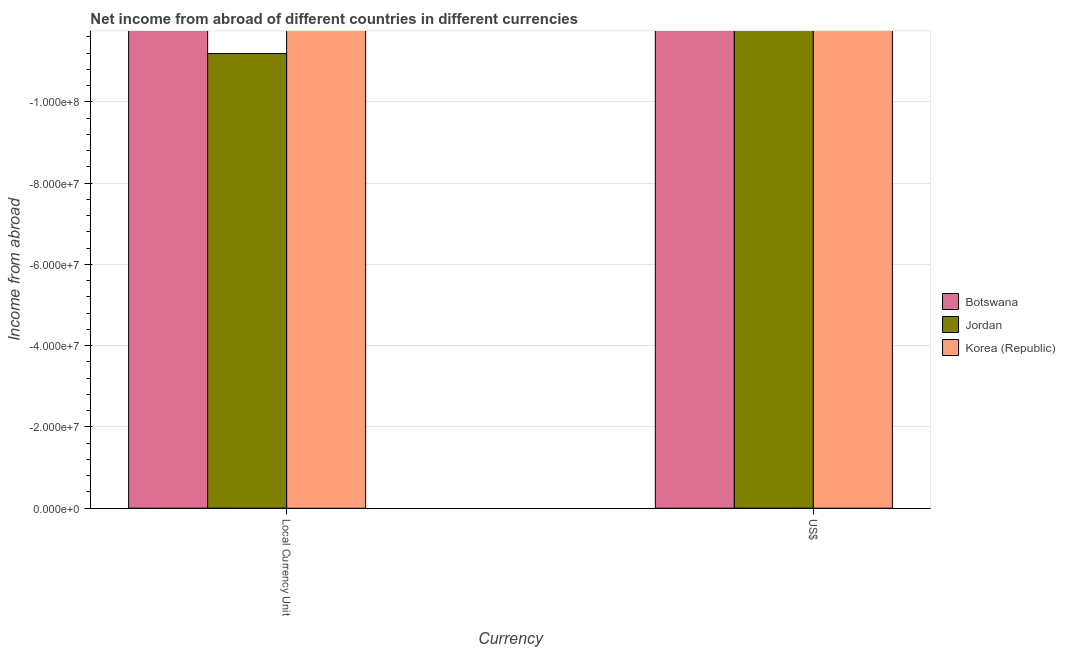Are the number of bars per tick equal to the number of legend labels?
Offer a terse response. No. Are the number of bars on each tick of the X-axis equal?
Your response must be concise. Yes. What is the label of the 2nd group of bars from the left?
Ensure brevity in your answer.  US$. What is the difference between the income from abroad in us$ in Korea (Republic) and the income from abroad in constant 2005 us$ in Jordan?
Offer a very short reply. 0. What is the average income from abroad in us$ per country?
Keep it short and to the point. 0. In how many countries, is the income from abroad in us$ greater than the average income from abroad in us$ taken over all countries?
Ensure brevity in your answer.  0. Are all the bars in the graph horizontal?
Your answer should be very brief. No. What is the difference between two consecutive major ticks on the Y-axis?
Provide a succinct answer. 2.00e+07. Where does the legend appear in the graph?
Your answer should be compact. Center right. How many legend labels are there?
Your answer should be very brief. 3. What is the title of the graph?
Ensure brevity in your answer.  Net income from abroad of different countries in different currencies. Does "Greece" appear as one of the legend labels in the graph?
Ensure brevity in your answer.  No. What is the label or title of the X-axis?
Provide a short and direct response. Currency. What is the label or title of the Y-axis?
Your answer should be very brief. Income from abroad. What is the Income from abroad in Botswana in US$?
Make the answer very short. 0. What is the total Income from abroad in Botswana in the graph?
Keep it short and to the point. 0. What is the total Income from abroad of Jordan in the graph?
Give a very brief answer. 0. What is the average Income from abroad of Botswana per Currency?
Provide a short and direct response. 0. What is the average Income from abroad of Korea (Republic) per Currency?
Your answer should be very brief. 0. 